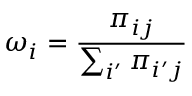Convert formula to latex. <formula><loc_0><loc_0><loc_500><loc_500>\omega _ { i } = \frac { \pi _ { i j } } { \sum _ { i ^ { \prime } } \pi _ { i ^ { \prime } j } }</formula> 